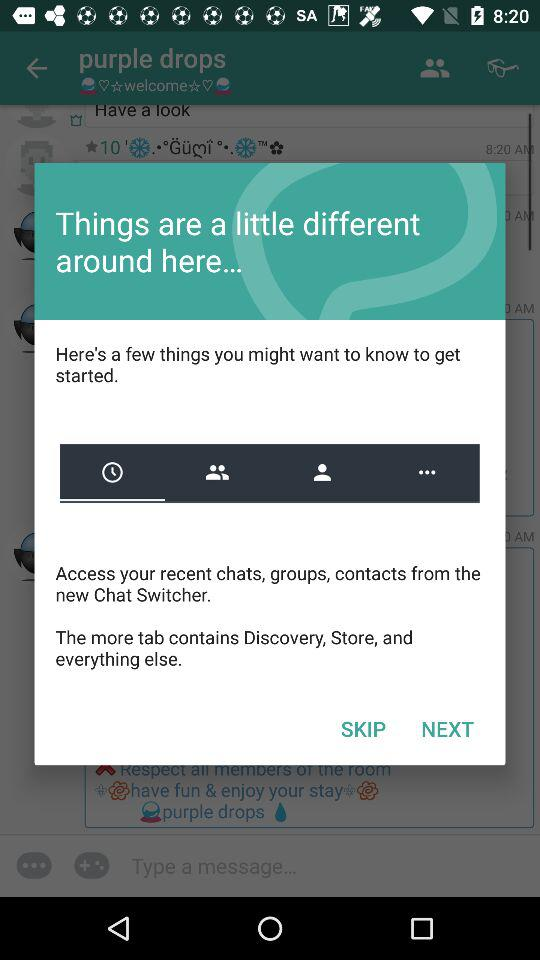From where can we access chats, groups and contacts? You can access chats, groups and contacts from the new Chat Switcher. 